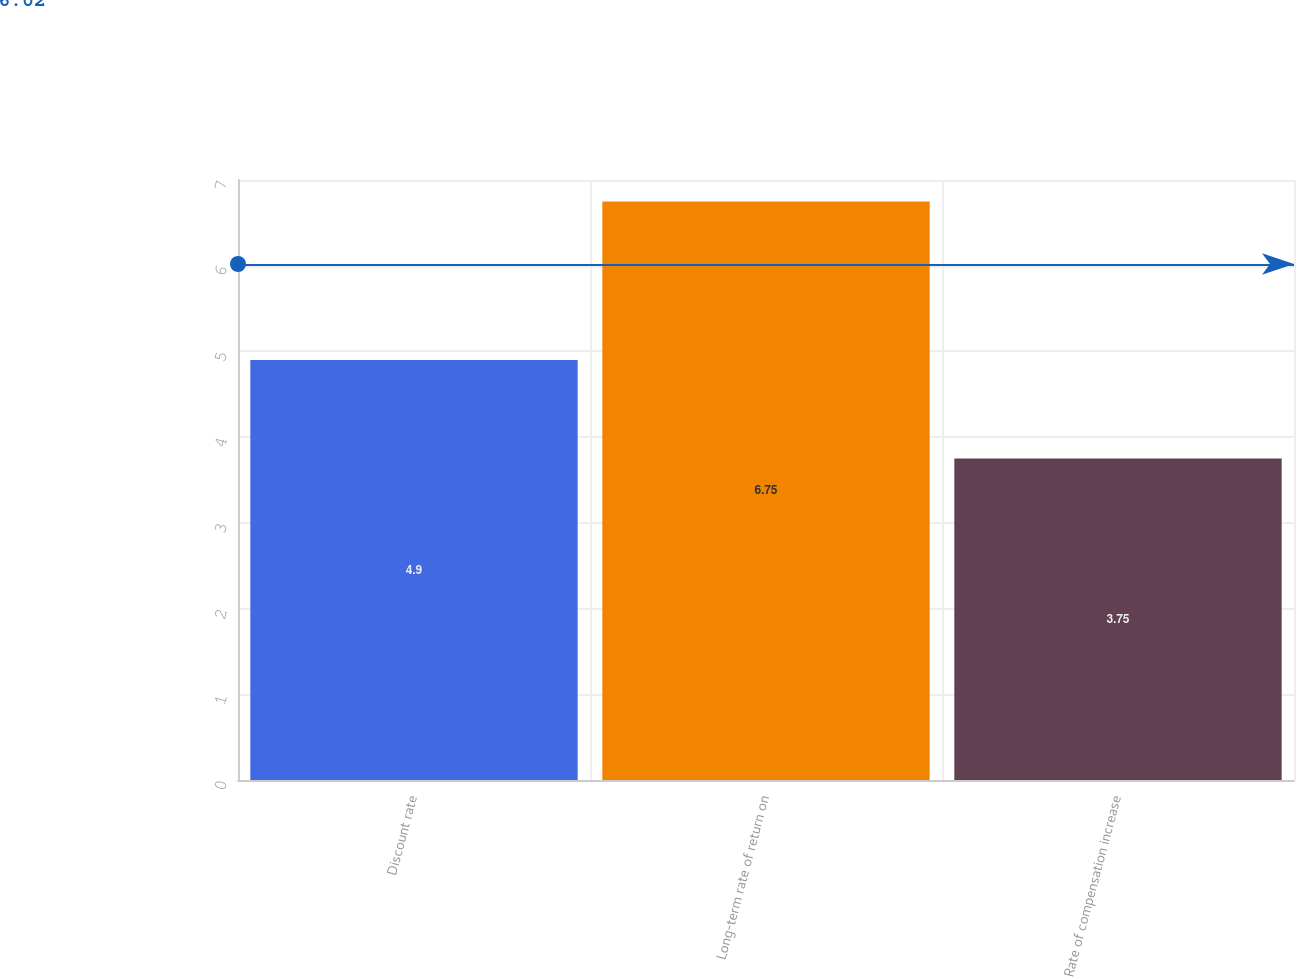<chart> <loc_0><loc_0><loc_500><loc_500><bar_chart><fcel>Discount rate<fcel>Long-term rate of return on<fcel>Rate of compensation increase<nl><fcel>4.9<fcel>6.75<fcel>3.75<nl></chart> 